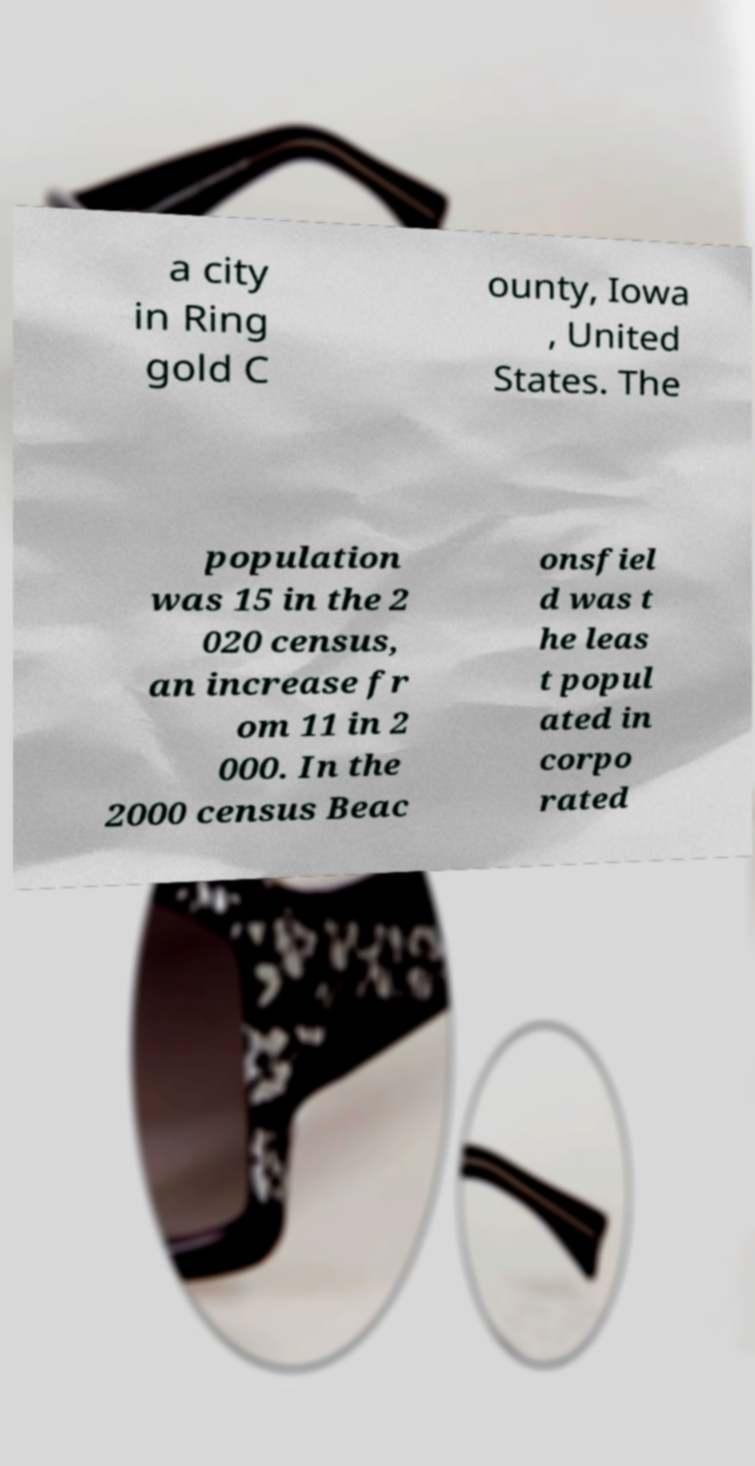Can you read and provide the text displayed in the image?This photo seems to have some interesting text. Can you extract and type it out for me? a city in Ring gold C ounty, Iowa , United States. The population was 15 in the 2 020 census, an increase fr om 11 in 2 000. In the 2000 census Beac onsfiel d was t he leas t popul ated in corpo rated 